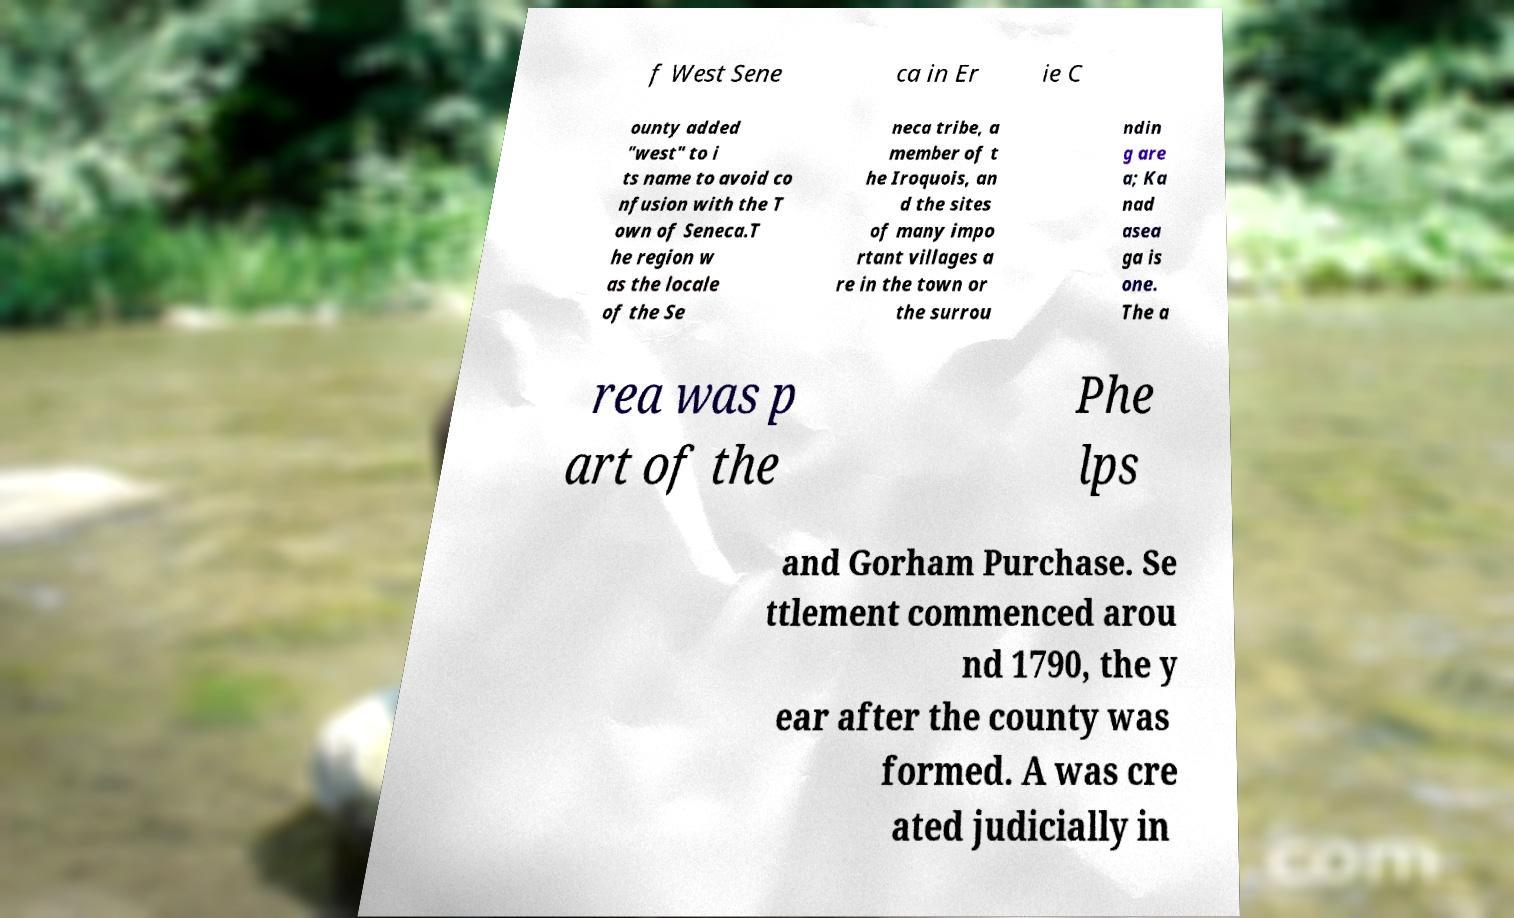There's text embedded in this image that I need extracted. Can you transcribe it verbatim? f West Sene ca in Er ie C ounty added "west" to i ts name to avoid co nfusion with the T own of Seneca.T he region w as the locale of the Se neca tribe, a member of t he Iroquois, an d the sites of many impo rtant villages a re in the town or the surrou ndin g are a; Ka nad asea ga is one. The a rea was p art of the Phe lps and Gorham Purchase. Se ttlement commenced arou nd 1790, the y ear after the county was formed. A was cre ated judicially in 